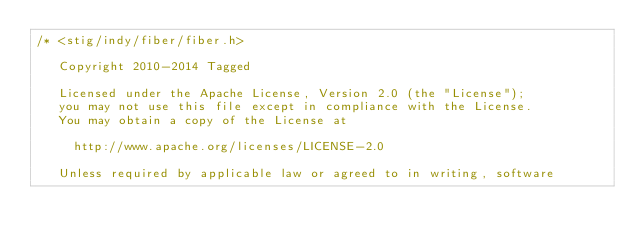<code> <loc_0><loc_0><loc_500><loc_500><_C_>/* <stig/indy/fiber/fiber.h> 

   Copyright 2010-2014 Tagged
   
   Licensed under the Apache License, Version 2.0 (the "License");
   you may not use this file except in compliance with the License.
   You may obtain a copy of the License at
   
     http://www.apache.org/licenses/LICENSE-2.0
   
   Unless required by applicable law or agreed to in writing, software</code> 